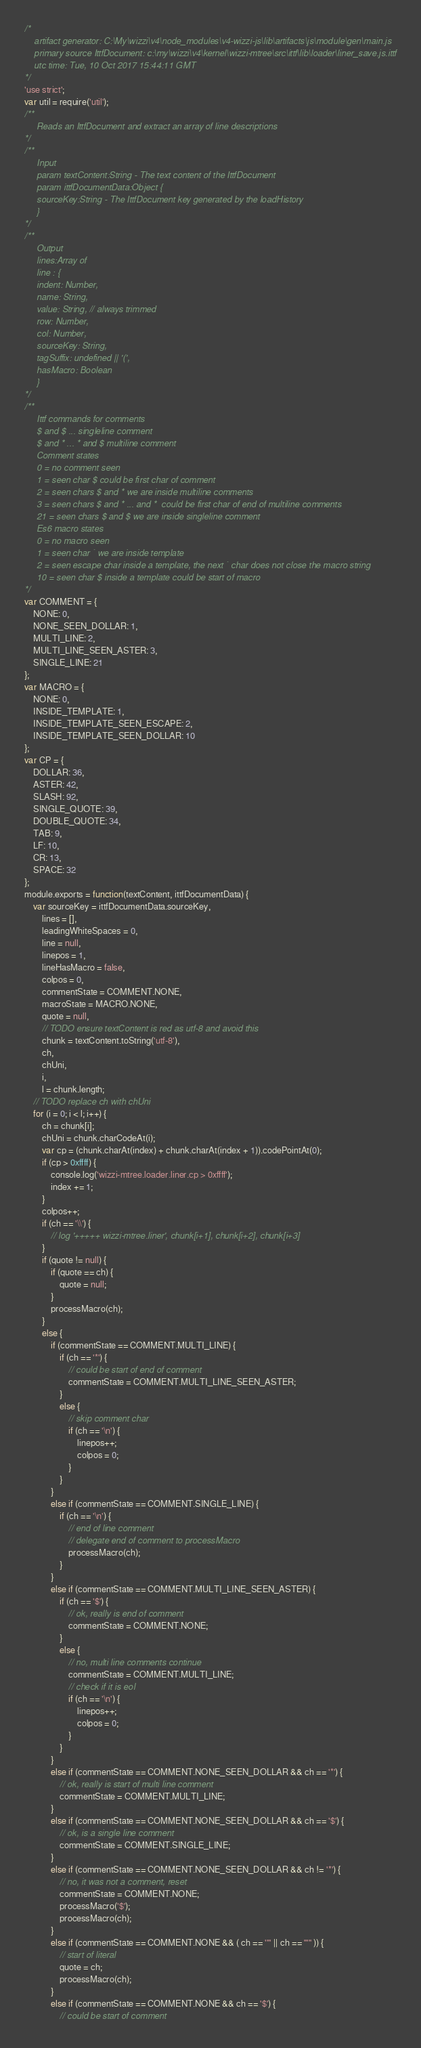<code> <loc_0><loc_0><loc_500><loc_500><_JavaScript_>/*
    artifact generator: C:\My\wizzi\v4\node_modules\v4-wizzi-js\lib\artifacts\js\module\gen\main.js
    primary source IttfDocument: c:\my\wizzi\v4\kernel\wizzi-mtree\src\ittf\lib\loader\liner_save.js.ittf
    utc time: Tue, 10 Oct 2017 15:44:11 GMT
*/
'use strict';
var util = require('util');
/**
     Reads an IttfDocument and extract an array of line descriptions
*/
/**
     Input
     param textContent:String - The text content of the IttfDocument
     param ittfDocumentData:Object {
     sourceKey:String - The IttfDocument key generated by the loadHistory
     }
*/
/**
     Output
     lines:Array of
     line : {
     indent: Number,
     name: String,
     value: String, // always trimmed
     row: Number,
     col: Number,
     sourceKey: String,
     tagSuffix: undefined || '(',
     hasMacro: Boolean
     }
*/
/**
     Ittf commands for comments
     $ and $ ... singleline comment
     $ and * ... * and $ multiline comment
     Comment states
     0 = no comment seen
     1 = seen char $ could be first char of comment
     2 = seen chars $ and * we are inside multiline comments
     3 = seen chars $ and * ... and *  could be first char of end of multiline comments
     21 = seen chars $ and $ we are inside singleline comment
     Es6 macro states
     0 = no macro seen
     1 = seen char ` we are inside template
     2 = seen escape char inside a template, the next ` char does not close the macro string
     10 = seen char $ inside a template could be start of macro
*/
var COMMENT = {
    NONE: 0, 
    NONE_SEEN_DOLLAR: 1, 
    MULTI_LINE: 2, 
    MULTI_LINE_SEEN_ASTER: 3, 
    SINGLE_LINE: 21
};
var MACRO = {
    NONE: 0, 
    INSIDE_TEMPLATE: 1, 
    INSIDE_TEMPLATE_SEEN_ESCAPE: 2, 
    INSIDE_TEMPLATE_SEEN_DOLLAR: 10
};
var CP = {
    DOLLAR: 36, 
    ASTER: 42, 
    SLASH: 92, 
    SINGLE_QUOTE: 39, 
    DOUBLE_QUOTE: 34, 
    TAB: 9, 
    LF: 10, 
    CR: 13, 
    SPACE: 32
};
module.exports = function(textContent, ittfDocumentData) {
    var sourceKey = ittfDocumentData.sourceKey,
        lines = [],
        leadingWhiteSpaces = 0,
        line = null,
        linepos = 1,
        lineHasMacro = false,
        colpos = 0,
        commentState = COMMENT.NONE,
        macroState = MACRO.NONE,
        quote = null,
        // TODO ensure textContent is red as utf-8 and avoid this
        chunk = textContent.toString('utf-8'),
        ch,
        chUni,
        i,
        l = chunk.length;
    // TODO replace ch with chUni
    for (i = 0; i < l; i++) {
        ch = chunk[i];
        chUni = chunk.charCodeAt(i);
        var cp = (chunk.charAt(index) + chunk.charAt(index + 1)).codePointAt(0);
        if (cp > 0xffff) {
            console.log('wizzi-mtree.loader.liner.cp > 0xffff');
            index += 1;
        }
        colpos++;
        if (ch == '\\') {
            // log '+++++ wizzi-mtree.liner', chunk[i+1], chunk[i+2], chunk[i+3]
        }
        if (quote != null) {
            if (quote == ch) {
                quote = null;
            }
            processMacro(ch);
        }
        else {
            if (commentState == COMMENT.MULTI_LINE) {
                if (ch == '*') {
                    // could be start of end of comment
                    commentState = COMMENT.MULTI_LINE_SEEN_ASTER;
                }
                else {
                    // skip comment char
                    if (ch == '\n') {
                        linepos++;
                        colpos = 0;
                    }
                }
            }
            else if (commentState == COMMENT.SINGLE_LINE) {
                if (ch == '\n') {
                    // end of line comment
                    // delegate end of comment to processMacro
                    processMacro(ch);
                }
            }
            else if (commentState == COMMENT.MULTI_LINE_SEEN_ASTER) {
                if (ch == '$') {
                    // ok, really is end of comment
                    commentState = COMMENT.NONE;
                }
                else {
                    // no, multi line comments continue
                    commentState = COMMENT.MULTI_LINE;
                    // check if it is eol
                    if (ch == '\n') {
                        linepos++;
                        colpos = 0;
                    }
                }
            }
            else if (commentState == COMMENT.NONE_SEEN_DOLLAR && ch == '*') {
                // ok, really is start of multi line comment
                commentState = COMMENT.MULTI_LINE;
            }
            else if (commentState == COMMENT.NONE_SEEN_DOLLAR && ch == '$') {
                // ok, is a single line comment
                commentState = COMMENT.SINGLE_LINE;
            }
            else if (commentState == COMMENT.NONE_SEEN_DOLLAR && ch != '*') {
                // no, it was not a comment, reset
                commentState = COMMENT.NONE;
                processMacro('$');
                processMacro(ch);
            }
            else if (commentState == COMMENT.NONE && ( ch == '"' || ch == "'" )) {
                // start of literal
                quote = ch;
                processMacro(ch);
            }
            else if (commentState == COMMENT.NONE && ch == '$') {
                // could be start of comment</code> 